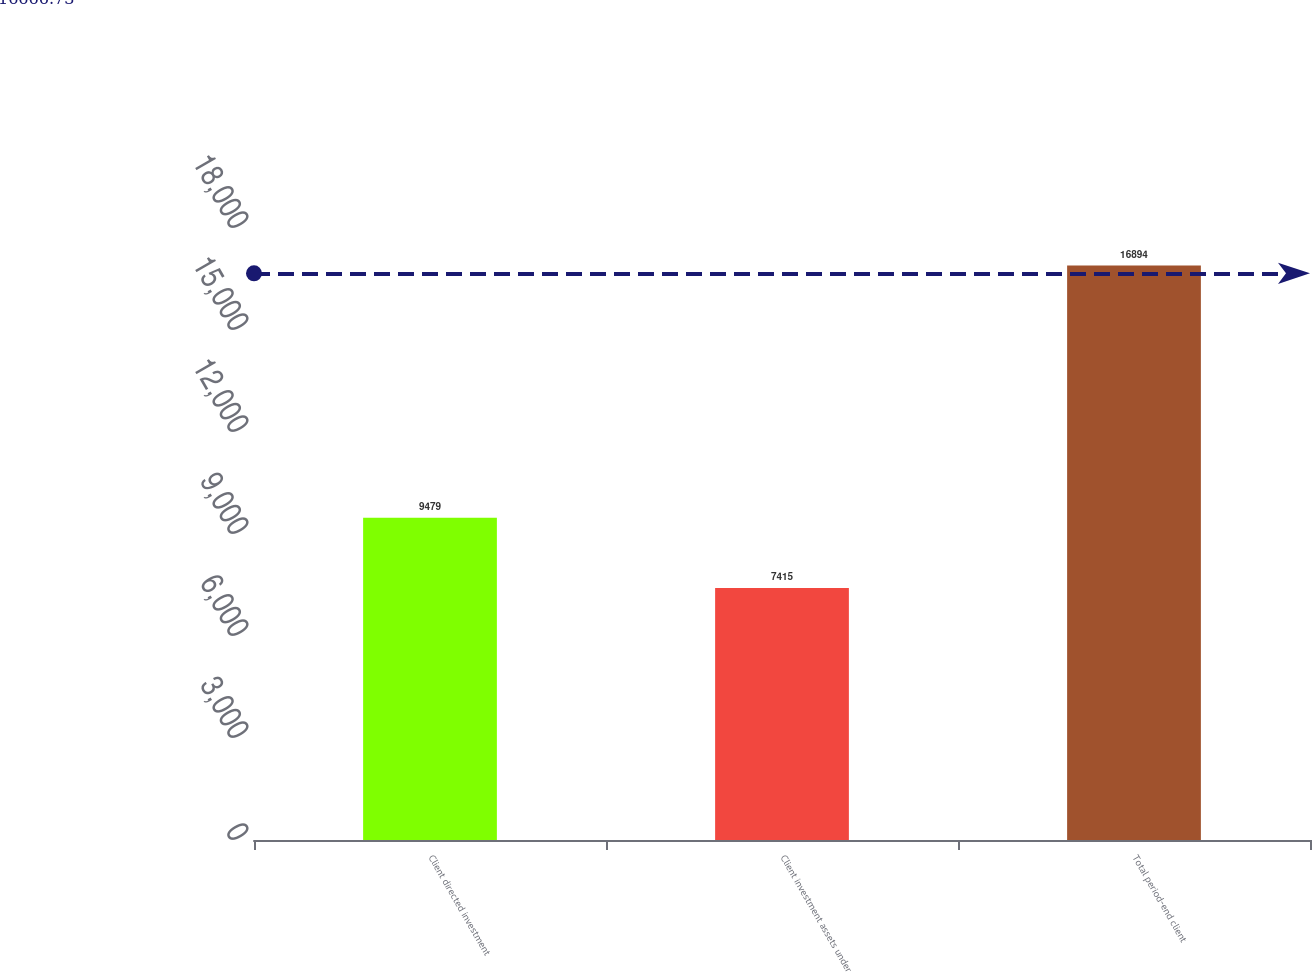Convert chart to OTSL. <chart><loc_0><loc_0><loc_500><loc_500><bar_chart><fcel>Client directed investment<fcel>Client investment assets under<fcel>Total period-end client<nl><fcel>9479<fcel>7415<fcel>16894<nl></chart> 